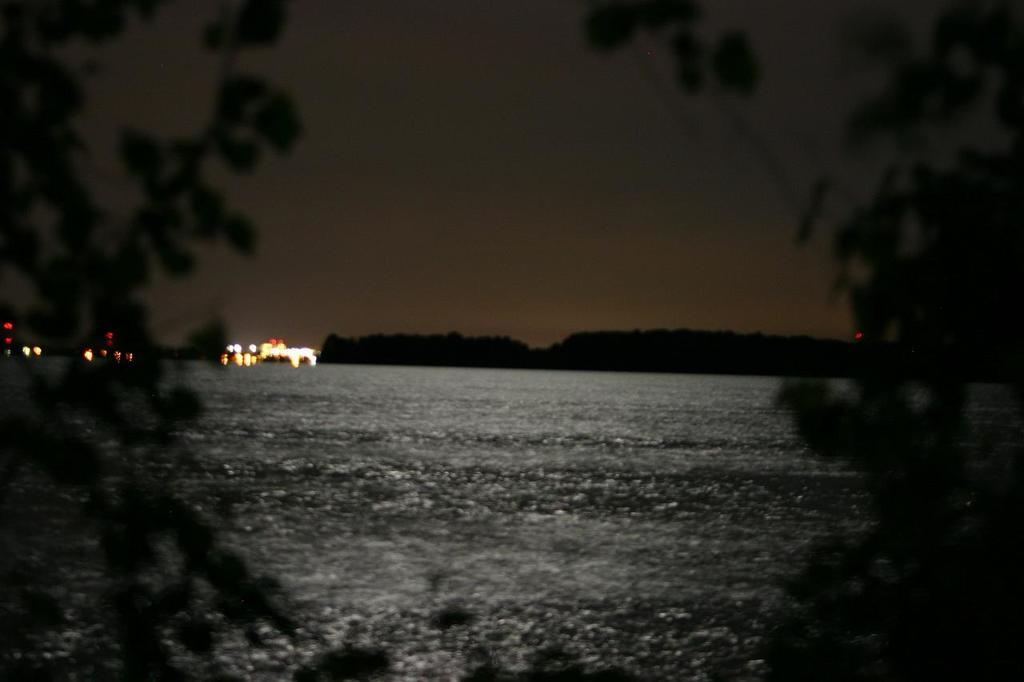What is the primary element visible in the image? There is water in the image. What type of vegetation can be seen in the image? There are trees in the image. What can be seen in the distance in the image? There are hills in the background of the image. What else is visible in the background of the image? There are lights and the sky visible in the background of the image. Where is the secretary sitting in the image? There is no secretary present in the image. What type of grass is growing near the water in the image? There is no grass visible in the image; it only shows water, trees, hills, lights, and the sky. 